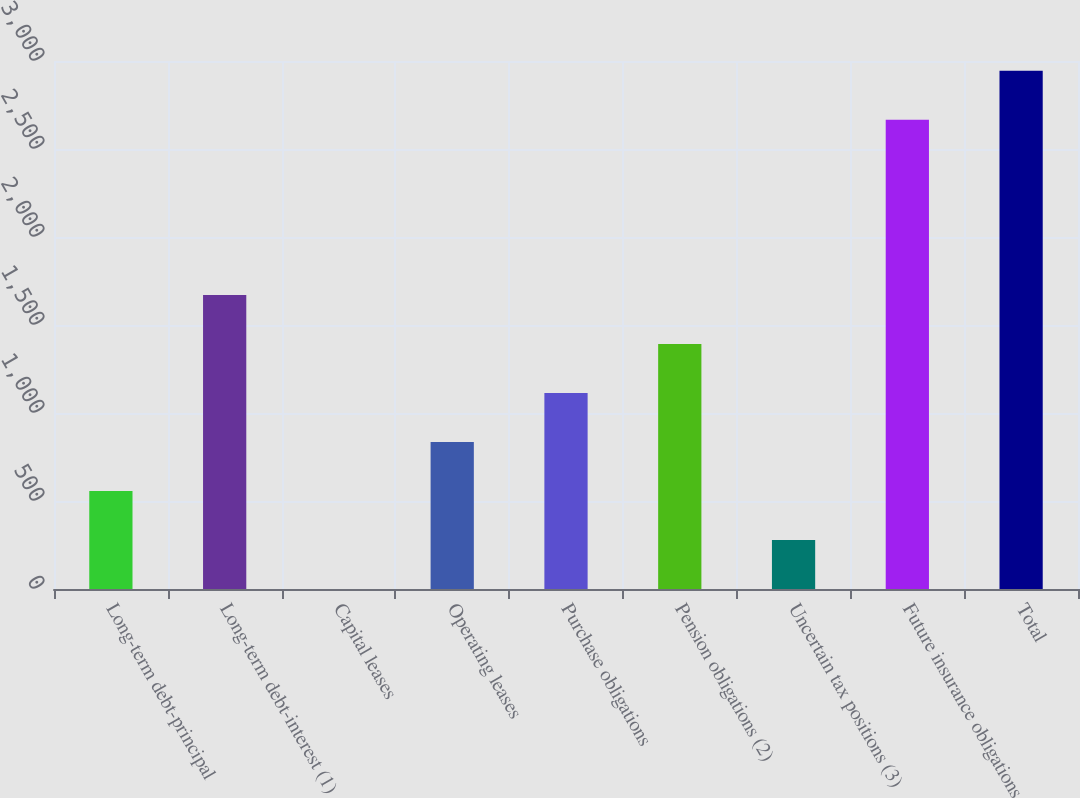Convert chart. <chart><loc_0><loc_0><loc_500><loc_500><bar_chart><fcel>Long-term debt-principal<fcel>Long-term debt-interest (1)<fcel>Capital leases<fcel>Operating leases<fcel>Purchase obligations<fcel>Pension obligations (2)<fcel>Uncertain tax positions (3)<fcel>Future insurance obligations<fcel>Total<nl><fcel>557.08<fcel>1670.52<fcel>0.36<fcel>835.44<fcel>1113.8<fcel>1392.16<fcel>278.72<fcel>2666<fcel>2944.36<nl></chart> 